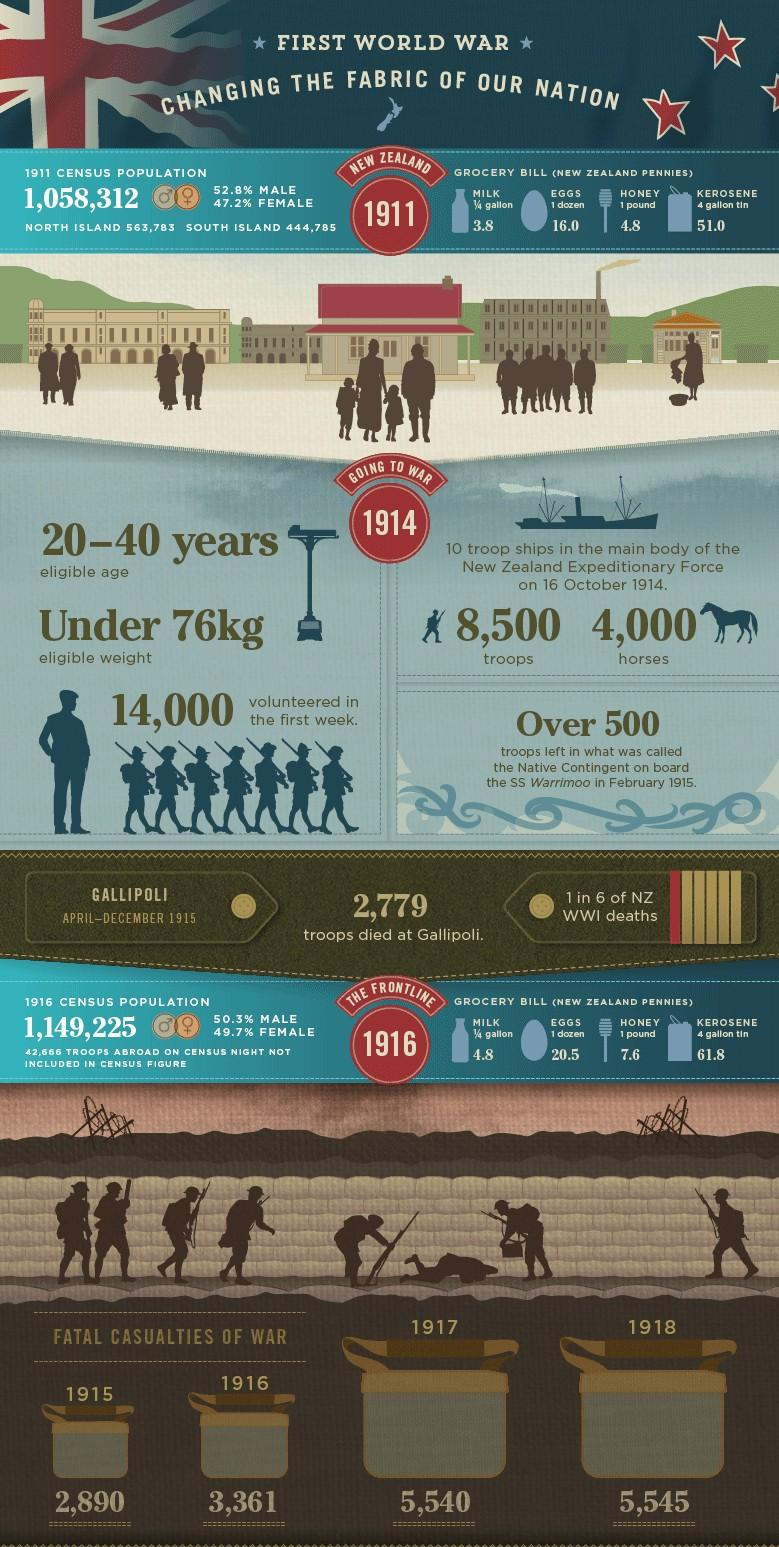Highlight a few significant elements in this photo. The price of eggs of one dozen in New Zealand increased from 1911 to 1916 by 4.5 pennies. The female population in the 1916 census was 49.7%. The total casualties of war in 1915 and 1916 taken together were 6,251. The year of 1918 reported the highest number of fatal casualties among all the years from 1914 to 1918. The price of kerosene for a 4-gallon container increased by 10.8 New Zealand pennies from 1911 to 1916. 